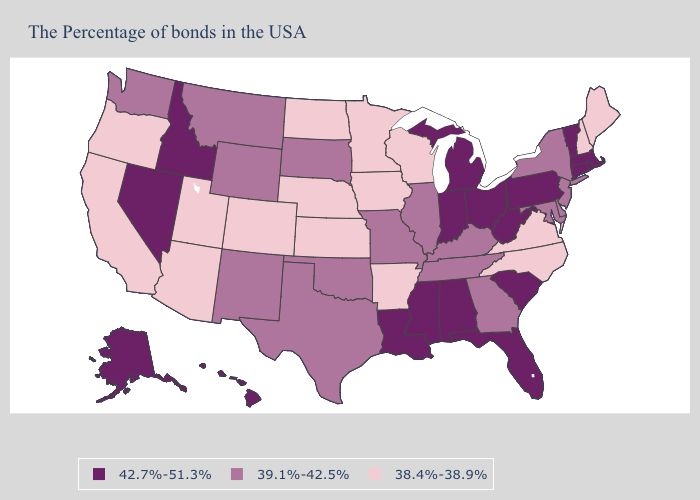Does the map have missing data?
Write a very short answer. No. Name the states that have a value in the range 39.1%-42.5%?
Answer briefly. New York, New Jersey, Delaware, Maryland, Georgia, Kentucky, Tennessee, Illinois, Missouri, Oklahoma, Texas, South Dakota, Wyoming, New Mexico, Montana, Washington. Does Louisiana have the highest value in the USA?
Answer briefly. Yes. Name the states that have a value in the range 38.4%-38.9%?
Keep it brief. Maine, New Hampshire, Virginia, North Carolina, Wisconsin, Arkansas, Minnesota, Iowa, Kansas, Nebraska, North Dakota, Colorado, Utah, Arizona, California, Oregon. Name the states that have a value in the range 39.1%-42.5%?
Be succinct. New York, New Jersey, Delaware, Maryland, Georgia, Kentucky, Tennessee, Illinois, Missouri, Oklahoma, Texas, South Dakota, Wyoming, New Mexico, Montana, Washington. What is the highest value in the South ?
Keep it brief. 42.7%-51.3%. Does the map have missing data?
Concise answer only. No. Name the states that have a value in the range 38.4%-38.9%?
Quick response, please. Maine, New Hampshire, Virginia, North Carolina, Wisconsin, Arkansas, Minnesota, Iowa, Kansas, Nebraska, North Dakota, Colorado, Utah, Arizona, California, Oregon. Does Arkansas have the lowest value in the South?
Give a very brief answer. Yes. What is the highest value in the USA?
Short answer required. 42.7%-51.3%. Name the states that have a value in the range 42.7%-51.3%?
Short answer required. Massachusetts, Rhode Island, Vermont, Connecticut, Pennsylvania, South Carolina, West Virginia, Ohio, Florida, Michigan, Indiana, Alabama, Mississippi, Louisiana, Idaho, Nevada, Alaska, Hawaii. What is the value of Iowa?
Be succinct. 38.4%-38.9%. Name the states that have a value in the range 38.4%-38.9%?
Quick response, please. Maine, New Hampshire, Virginia, North Carolina, Wisconsin, Arkansas, Minnesota, Iowa, Kansas, Nebraska, North Dakota, Colorado, Utah, Arizona, California, Oregon. Does Colorado have a lower value than California?
Answer briefly. No. What is the value of Oklahoma?
Be succinct. 39.1%-42.5%. 